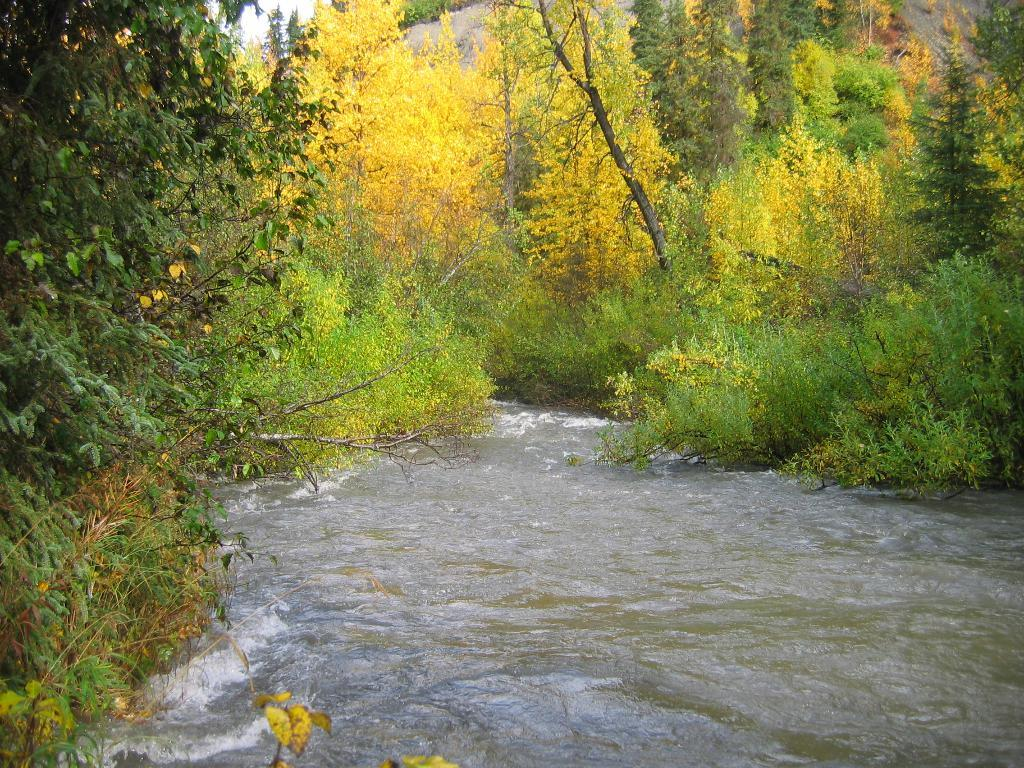What type of vegetation can be seen in the image? There are many trees and plants in the image. What natural element is visible in the image? There is water visible in the image. What part of the natural environment is visible in the image? The sky is visible in the image. What type of string can be seen tied around the trees in the image? There is no string tied around the trees in the image; only trees, plants, water, and the sky are visible. 